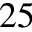Convert formula to latex. <formula><loc_0><loc_0><loc_500><loc_500>2 5</formula> 